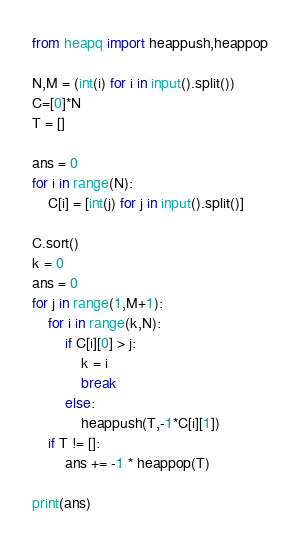Convert code to text. <code><loc_0><loc_0><loc_500><loc_500><_Python_>from heapq import heappush,heappop

N,M = (int(i) for i in input().split())
C=[0]*N
T = []

ans = 0
for i in range(N):
    C[i] = [int(j) for j in input().split()]

C.sort()
k = 0
ans = 0
for j in range(1,M+1):
    for i in range(k,N):
        if C[i][0] > j:
            k = i
            break
        else:
            heappush(T,-1*C[i][1])
    if T != []:
        ans += -1 * heappop(T)

print(ans)
</code> 